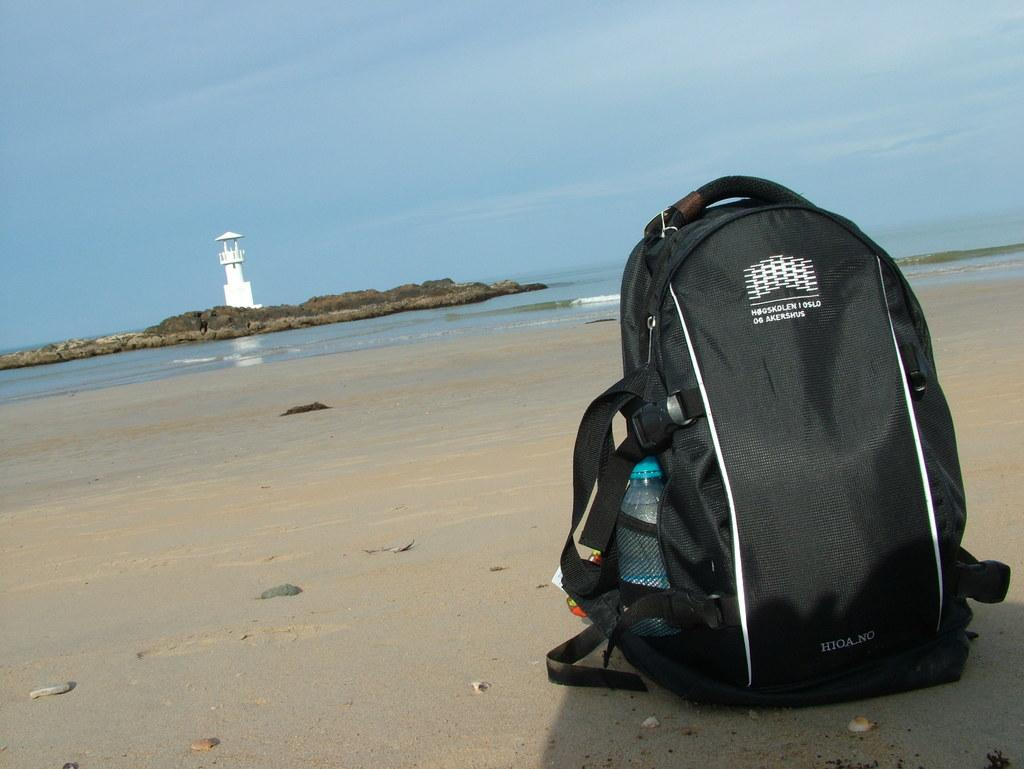<image>
Render a clear and concise summary of the photo. A backpack with "HIOA.NO" written on it on a beach 